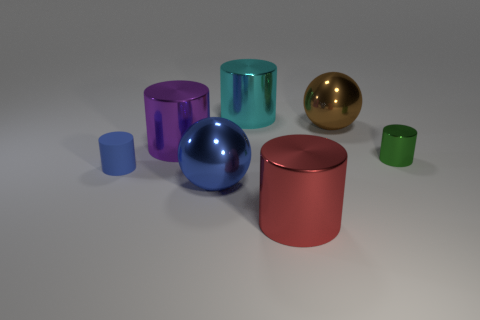How would you explain the significance of lighting in this image? Lighting plays a crucial role in this image, highlighting the reflective nature of the materials and creating a mood that is both realistic and aesthetically pleasing. The soft shadows on the ground suggest a diffused light source, which helps to accentuate the three-dimensional aspect of the objects. The careful placement of the light elevates the visual harmony and balance, drawing attention to the shapes and colors of the objects without creating harsh contrasts. 